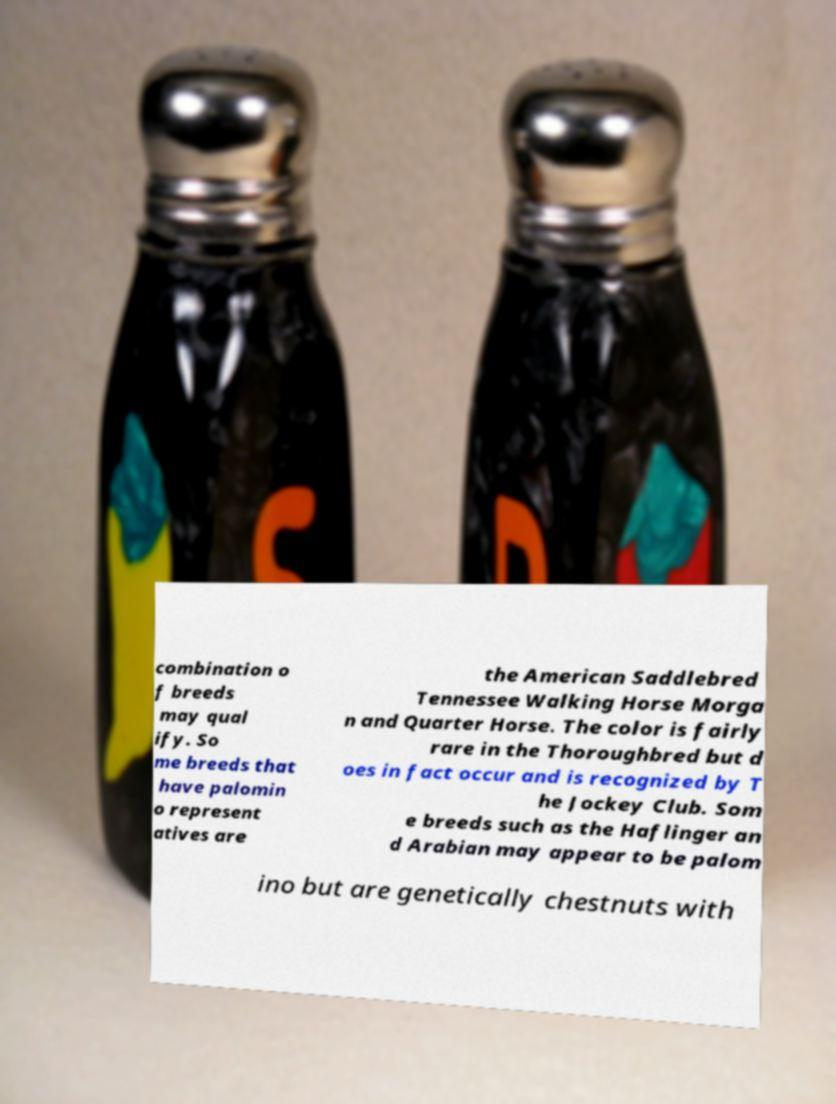Can you accurately transcribe the text from the provided image for me? combination o f breeds may qual ify. So me breeds that have palomin o represent atives are the American Saddlebred Tennessee Walking Horse Morga n and Quarter Horse. The color is fairly rare in the Thoroughbred but d oes in fact occur and is recognized by T he Jockey Club. Som e breeds such as the Haflinger an d Arabian may appear to be palom ino but are genetically chestnuts with 